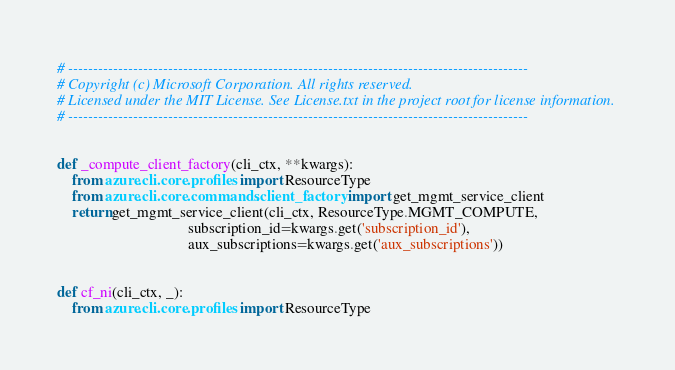Convert code to text. <code><loc_0><loc_0><loc_500><loc_500><_Python_># --------------------------------------------------------------------------------------------
# Copyright (c) Microsoft Corporation. All rights reserved.
# Licensed under the MIT License. See License.txt in the project root for license information.
# --------------------------------------------------------------------------------------------


def _compute_client_factory(cli_ctx, **kwargs):
    from azure.cli.core.profiles import ResourceType
    from azure.cli.core.commands.client_factory import get_mgmt_service_client
    return get_mgmt_service_client(cli_ctx, ResourceType.MGMT_COMPUTE,
                                   subscription_id=kwargs.get('subscription_id'),
                                   aux_subscriptions=kwargs.get('aux_subscriptions'))


def cf_ni(cli_ctx, _):
    from azure.cli.core.profiles import ResourceType</code> 